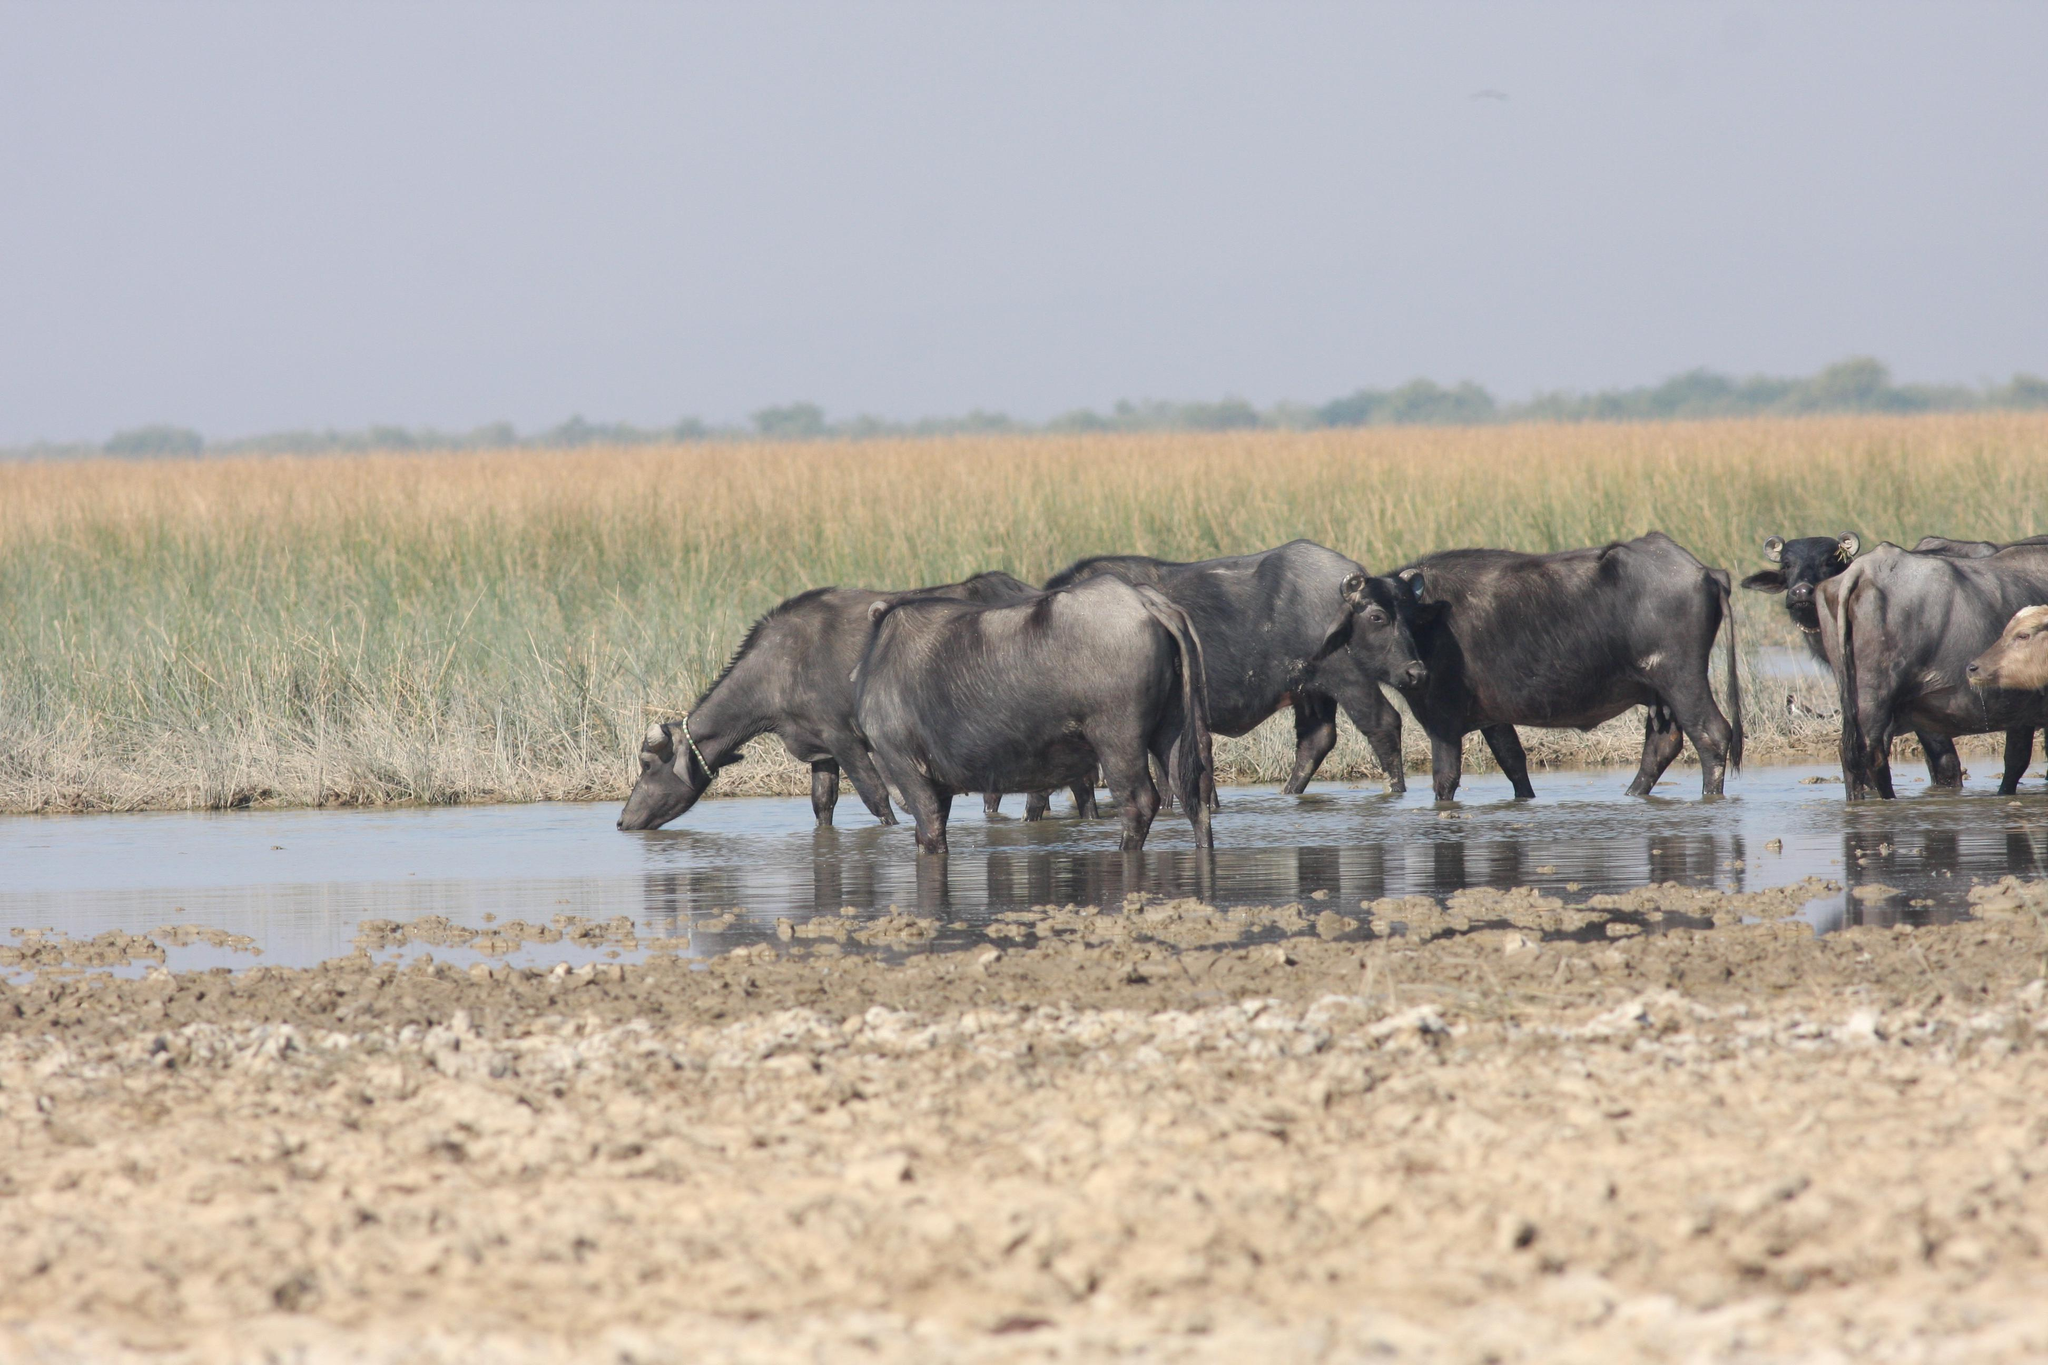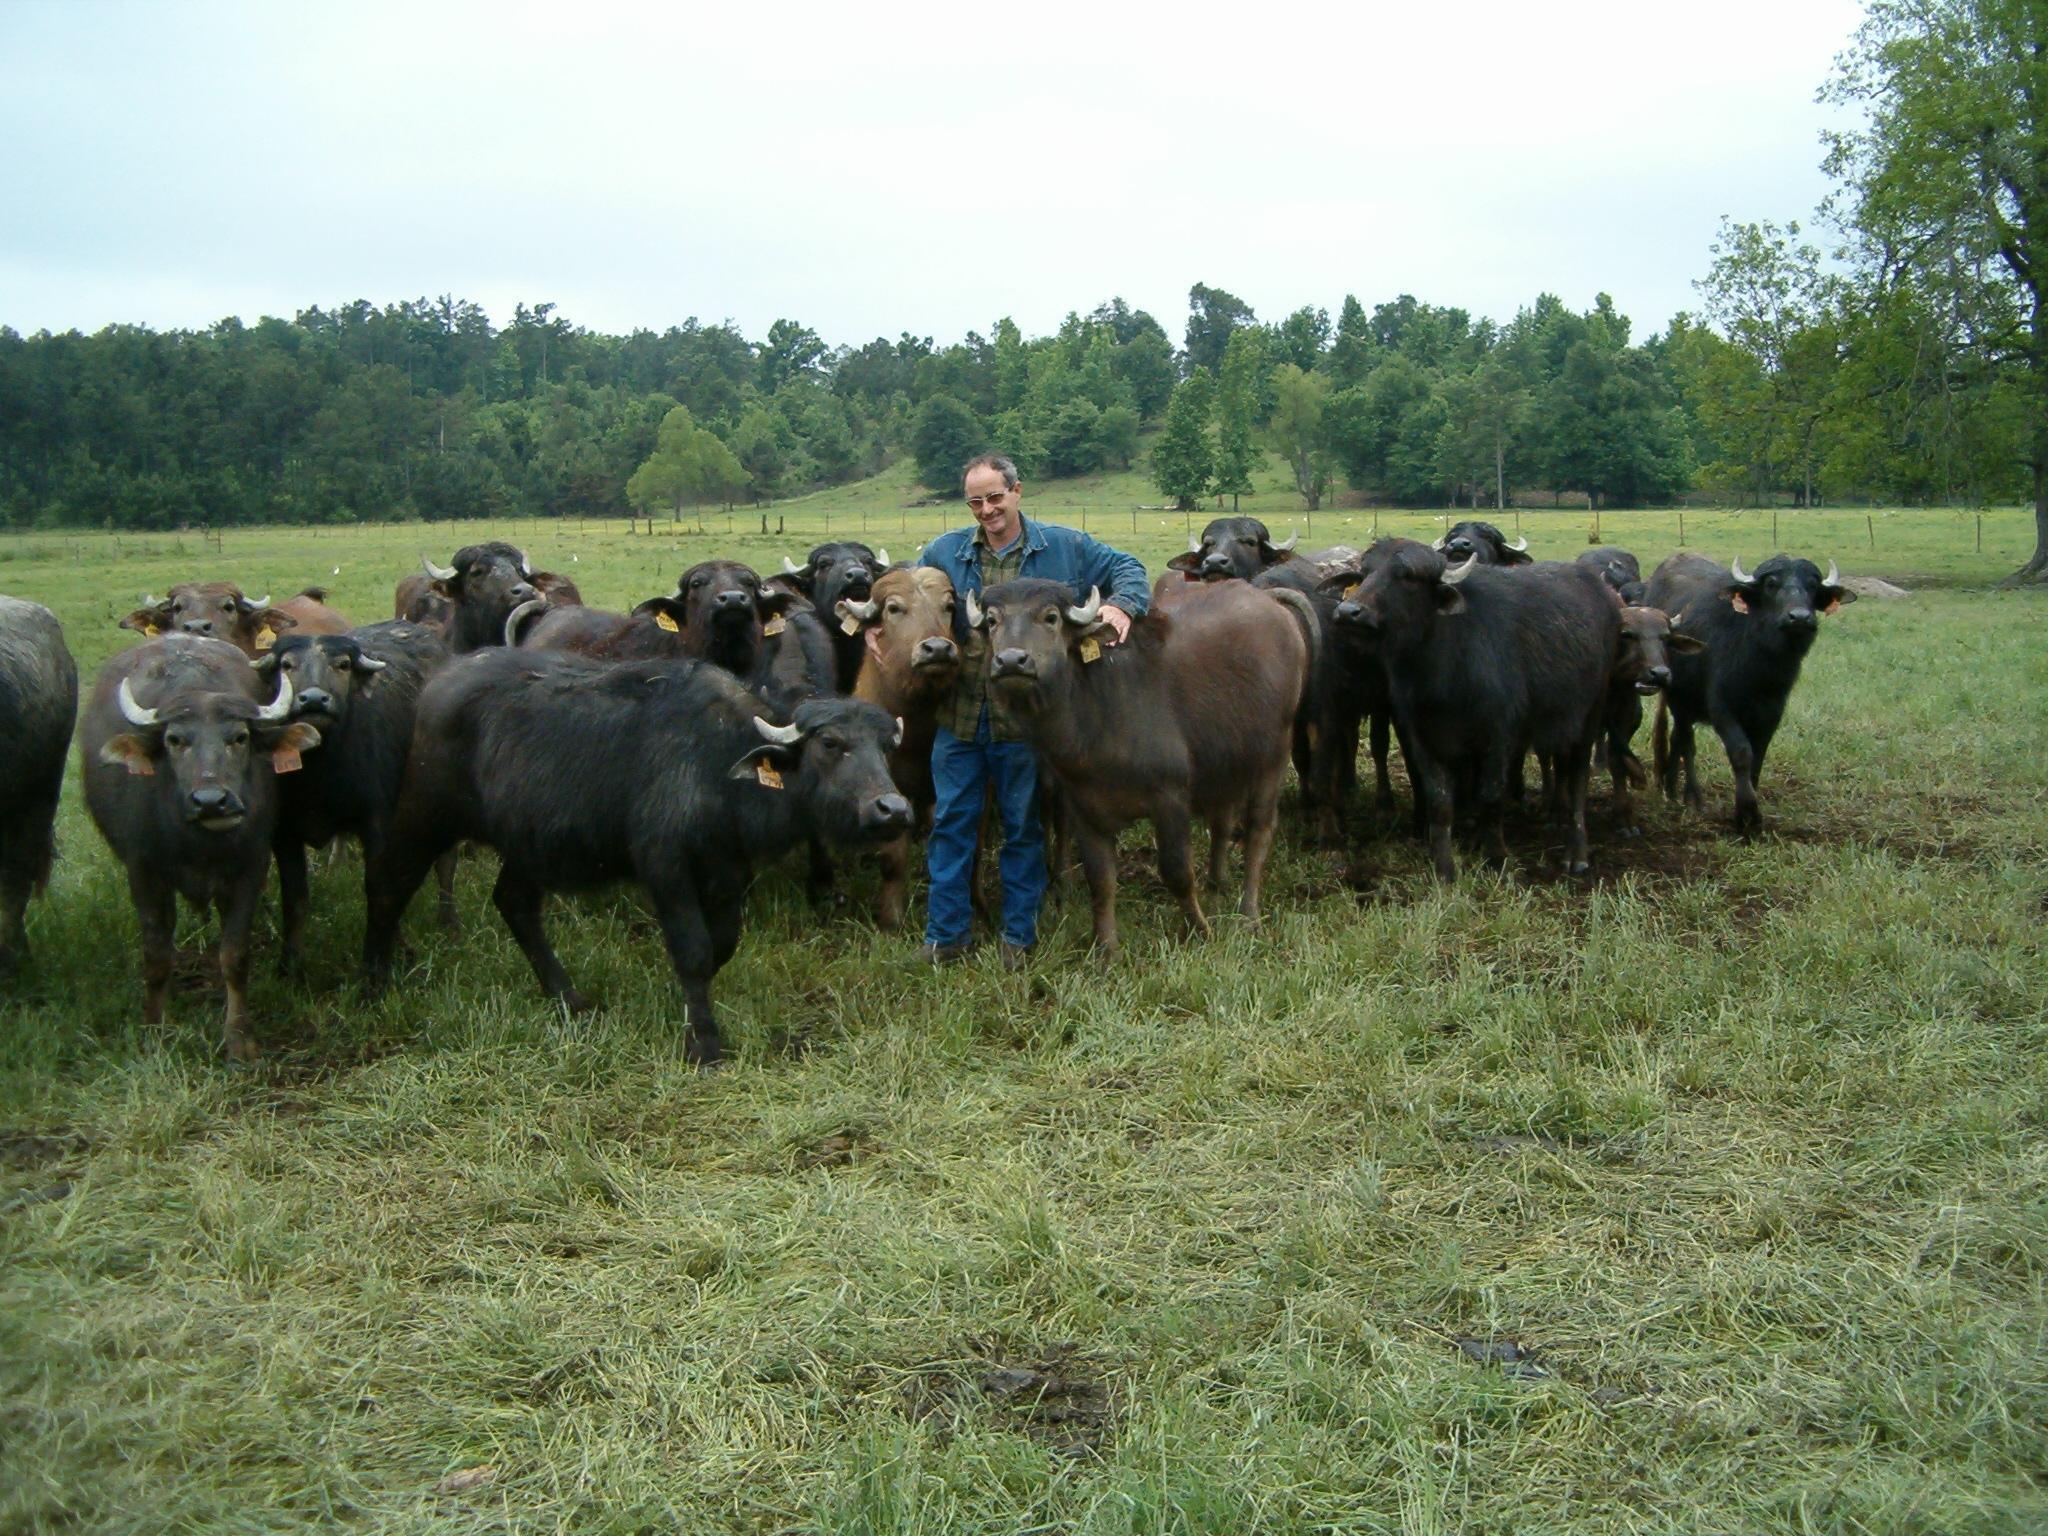The first image is the image on the left, the second image is the image on the right. For the images shown, is this caption "A person wearing bright blue is in the middle of a large group of oxen in one image." true? Answer yes or no. Yes. The first image is the image on the left, the second image is the image on the right. Considering the images on both sides, is "There is at one man with a blue shirt in the middle of at least 10 horned oxes." valid? Answer yes or no. Yes. 